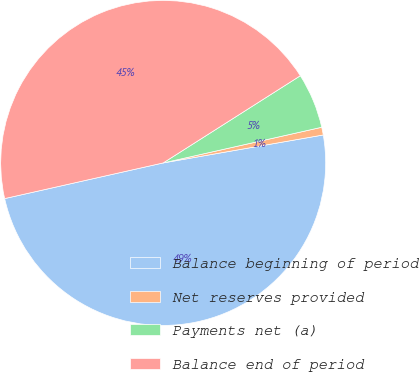<chart> <loc_0><loc_0><loc_500><loc_500><pie_chart><fcel>Balance beginning of period<fcel>Net reserves provided<fcel>Payments net (a)<fcel>Balance end of period<nl><fcel>49.23%<fcel>0.77%<fcel>5.49%<fcel>44.51%<nl></chart> 